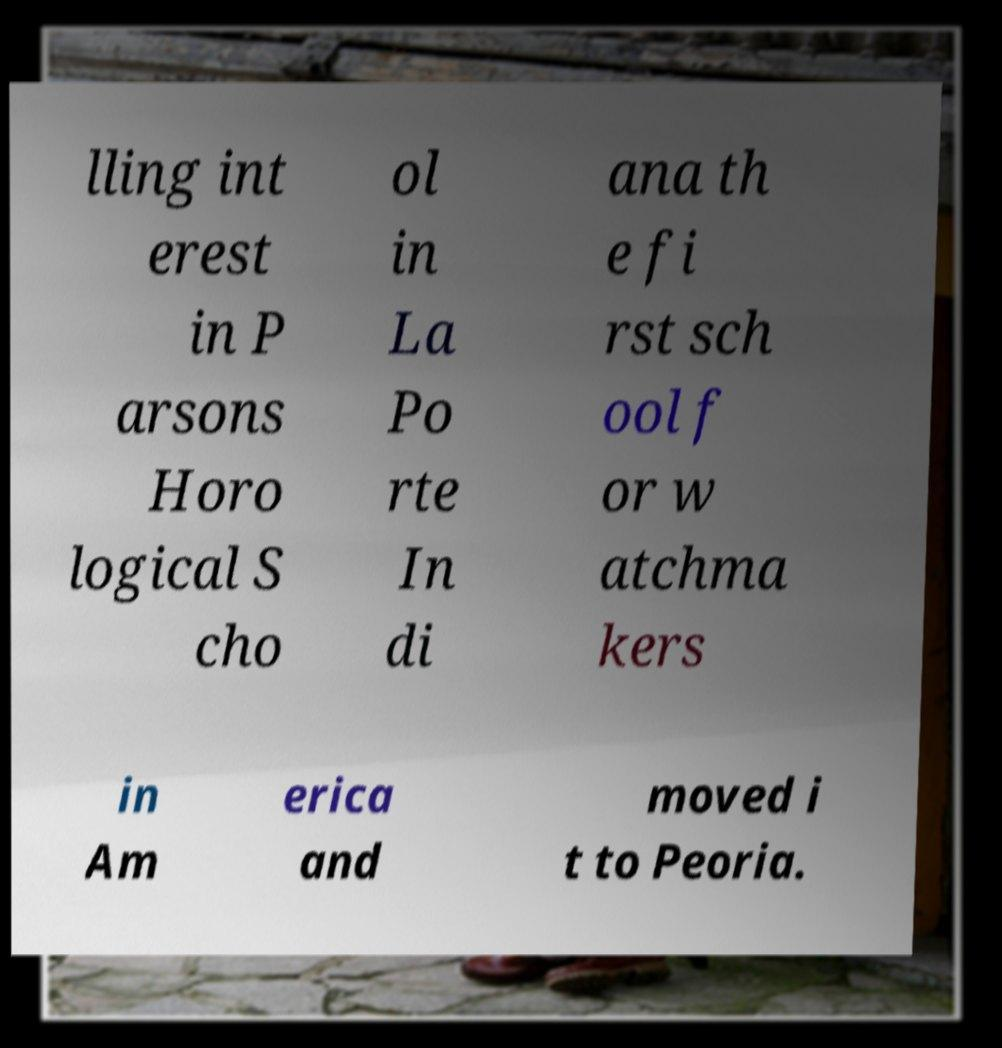Can you accurately transcribe the text from the provided image for me? lling int erest in P arsons Horo logical S cho ol in La Po rte In di ana th e fi rst sch ool f or w atchma kers in Am erica and moved i t to Peoria. 